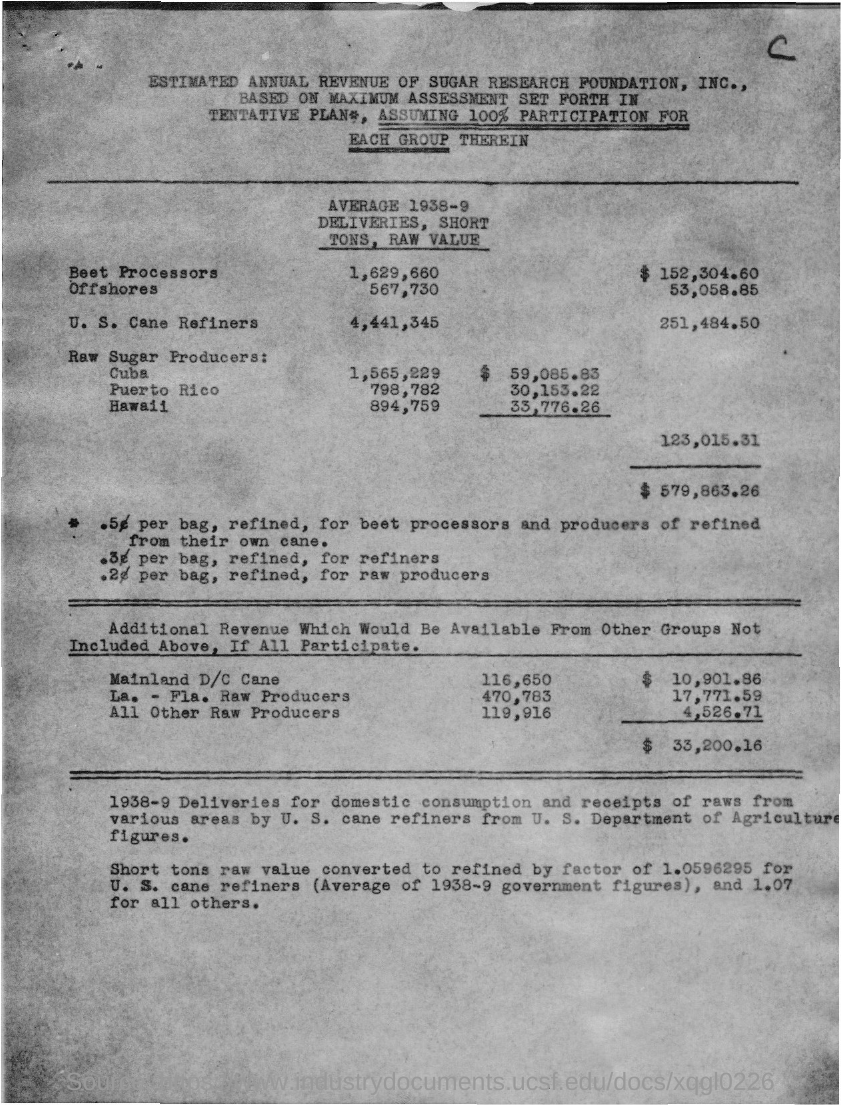Mention "AVERAGAE 1938-9 DELIVERIES, SHORT TONS, RAW VALUE" of "Beet Processors"?
Provide a succinct answer. 1,629,660. Mention "AVERAGAE 1938-9 DELIVERIES, SHORT TONS, RAW VALUE" of "Offshores"?
Ensure brevity in your answer.  567,730. Mention "AVERAGAE 1938-9 DELIVERIES, SHORT TONS, RAW VALUE" of "U.S. Cane Refiners"?
Give a very brief answer. 4,441,345. What is the name of the first "Raw Sugar Producers:" given?
Your answer should be compact. Cuba. Mention "AVERAGAE 1938-9 DELIVERIES, SHORT TONS, RAW VALUE" of "Cuba"?
Ensure brevity in your answer.  1,565,229. Mention "AVERAGAE 1938-9 DELIVERIES, SHORT TONS, RAW VALUE" of "Puerto Rico"?
Offer a terse response. 798,782. Mention "AVERAGAE 1938-9 DELIVERIES, SHORT TONS, RAW VALUE" of "Hawaii"?
Provide a succinct answer. 894,759. 